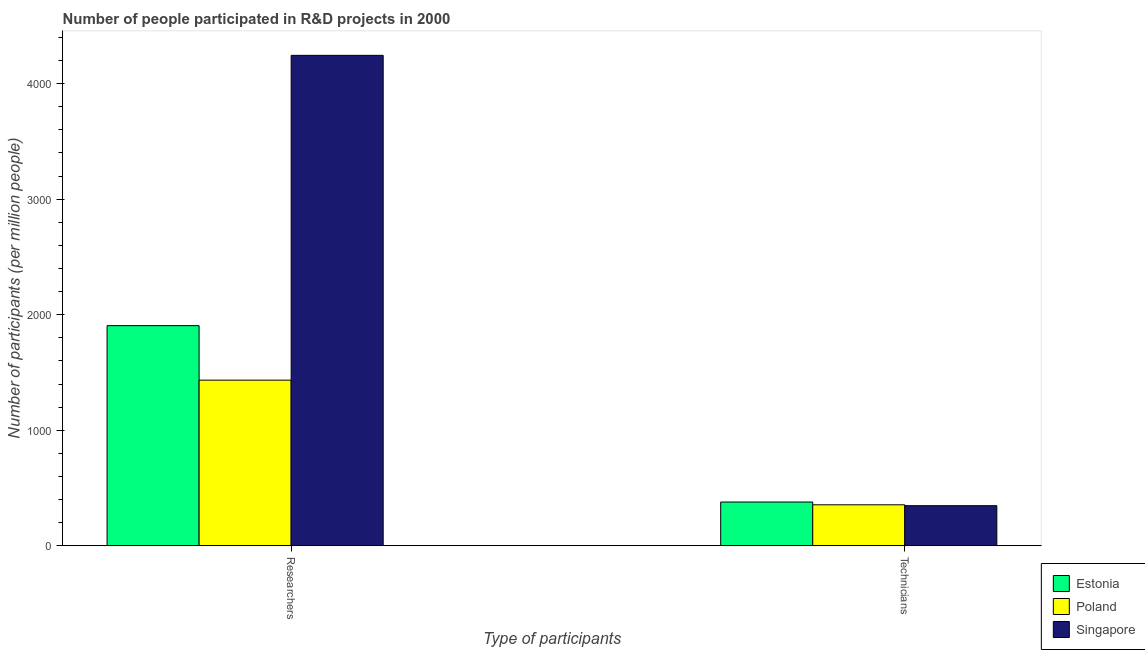Are the number of bars per tick equal to the number of legend labels?
Keep it short and to the point. Yes. Are the number of bars on each tick of the X-axis equal?
Keep it short and to the point. Yes. How many bars are there on the 2nd tick from the left?
Your answer should be very brief. 3. How many bars are there on the 1st tick from the right?
Your answer should be very brief. 3. What is the label of the 2nd group of bars from the left?
Give a very brief answer. Technicians. What is the number of researchers in Estonia?
Offer a very short reply. 1905.45. Across all countries, what is the maximum number of researchers?
Provide a succinct answer. 4245.03. Across all countries, what is the minimum number of researchers?
Give a very brief answer. 1433.6. In which country was the number of researchers maximum?
Make the answer very short. Singapore. In which country was the number of researchers minimum?
Your response must be concise. Poland. What is the total number of researchers in the graph?
Offer a very short reply. 7584.08. What is the difference between the number of researchers in Poland and that in Estonia?
Your response must be concise. -471.85. What is the difference between the number of researchers in Singapore and the number of technicians in Poland?
Provide a short and direct response. 3890.41. What is the average number of researchers per country?
Keep it short and to the point. 2528.03. What is the difference between the number of researchers and number of technicians in Estonia?
Keep it short and to the point. 1526.65. What is the ratio of the number of technicians in Poland to that in Estonia?
Your answer should be compact. 0.94. Is the number of researchers in Estonia less than that in Poland?
Your answer should be compact. No. What does the 1st bar from the left in Researchers represents?
Provide a short and direct response. Estonia. What does the 3rd bar from the right in Technicians represents?
Your answer should be compact. Estonia. How many countries are there in the graph?
Provide a short and direct response. 3. Does the graph contain any zero values?
Your answer should be compact. No. Where does the legend appear in the graph?
Keep it short and to the point. Bottom right. How many legend labels are there?
Your answer should be compact. 3. What is the title of the graph?
Offer a terse response. Number of people participated in R&D projects in 2000. What is the label or title of the X-axis?
Your answer should be compact. Type of participants. What is the label or title of the Y-axis?
Offer a terse response. Number of participants (per million people). What is the Number of participants (per million people) in Estonia in Researchers?
Offer a very short reply. 1905.45. What is the Number of participants (per million people) in Poland in Researchers?
Your answer should be very brief. 1433.6. What is the Number of participants (per million people) in Singapore in Researchers?
Provide a succinct answer. 4245.03. What is the Number of participants (per million people) in Estonia in Technicians?
Your answer should be very brief. 378.8. What is the Number of participants (per million people) in Poland in Technicians?
Make the answer very short. 354.62. What is the Number of participants (per million people) of Singapore in Technicians?
Provide a short and direct response. 347.1. Across all Type of participants, what is the maximum Number of participants (per million people) in Estonia?
Your answer should be compact. 1905.45. Across all Type of participants, what is the maximum Number of participants (per million people) in Poland?
Ensure brevity in your answer.  1433.6. Across all Type of participants, what is the maximum Number of participants (per million people) of Singapore?
Offer a terse response. 4245.03. Across all Type of participants, what is the minimum Number of participants (per million people) of Estonia?
Give a very brief answer. 378.8. Across all Type of participants, what is the minimum Number of participants (per million people) of Poland?
Your response must be concise. 354.62. Across all Type of participants, what is the minimum Number of participants (per million people) of Singapore?
Ensure brevity in your answer.  347.1. What is the total Number of participants (per million people) of Estonia in the graph?
Provide a succinct answer. 2284.25. What is the total Number of participants (per million people) in Poland in the graph?
Provide a succinct answer. 1788.22. What is the total Number of participants (per million people) in Singapore in the graph?
Make the answer very short. 4592.13. What is the difference between the Number of participants (per million people) of Estonia in Researchers and that in Technicians?
Your answer should be compact. 1526.65. What is the difference between the Number of participants (per million people) in Poland in Researchers and that in Technicians?
Provide a succinct answer. 1078.98. What is the difference between the Number of participants (per million people) of Singapore in Researchers and that in Technicians?
Provide a succinct answer. 3897.93. What is the difference between the Number of participants (per million people) in Estonia in Researchers and the Number of participants (per million people) in Poland in Technicians?
Provide a succinct answer. 1550.83. What is the difference between the Number of participants (per million people) in Estonia in Researchers and the Number of participants (per million people) in Singapore in Technicians?
Give a very brief answer. 1558.35. What is the difference between the Number of participants (per million people) in Poland in Researchers and the Number of participants (per million people) in Singapore in Technicians?
Offer a terse response. 1086.5. What is the average Number of participants (per million people) in Estonia per Type of participants?
Ensure brevity in your answer.  1142.13. What is the average Number of participants (per million people) in Poland per Type of participants?
Give a very brief answer. 894.11. What is the average Number of participants (per million people) of Singapore per Type of participants?
Your answer should be compact. 2296.06. What is the difference between the Number of participants (per million people) in Estonia and Number of participants (per million people) in Poland in Researchers?
Offer a very short reply. 471.85. What is the difference between the Number of participants (per million people) of Estonia and Number of participants (per million people) of Singapore in Researchers?
Offer a terse response. -2339.58. What is the difference between the Number of participants (per million people) in Poland and Number of participants (per million people) in Singapore in Researchers?
Your answer should be very brief. -2811.43. What is the difference between the Number of participants (per million people) in Estonia and Number of participants (per million people) in Poland in Technicians?
Ensure brevity in your answer.  24.18. What is the difference between the Number of participants (per million people) in Estonia and Number of participants (per million people) in Singapore in Technicians?
Give a very brief answer. 31.71. What is the difference between the Number of participants (per million people) of Poland and Number of participants (per million people) of Singapore in Technicians?
Offer a terse response. 7.52. What is the ratio of the Number of participants (per million people) in Estonia in Researchers to that in Technicians?
Make the answer very short. 5.03. What is the ratio of the Number of participants (per million people) in Poland in Researchers to that in Technicians?
Your response must be concise. 4.04. What is the ratio of the Number of participants (per million people) of Singapore in Researchers to that in Technicians?
Provide a succinct answer. 12.23. What is the difference between the highest and the second highest Number of participants (per million people) of Estonia?
Keep it short and to the point. 1526.65. What is the difference between the highest and the second highest Number of participants (per million people) of Poland?
Offer a terse response. 1078.98. What is the difference between the highest and the second highest Number of participants (per million people) in Singapore?
Your answer should be very brief. 3897.93. What is the difference between the highest and the lowest Number of participants (per million people) of Estonia?
Your answer should be very brief. 1526.65. What is the difference between the highest and the lowest Number of participants (per million people) of Poland?
Keep it short and to the point. 1078.98. What is the difference between the highest and the lowest Number of participants (per million people) in Singapore?
Keep it short and to the point. 3897.93. 